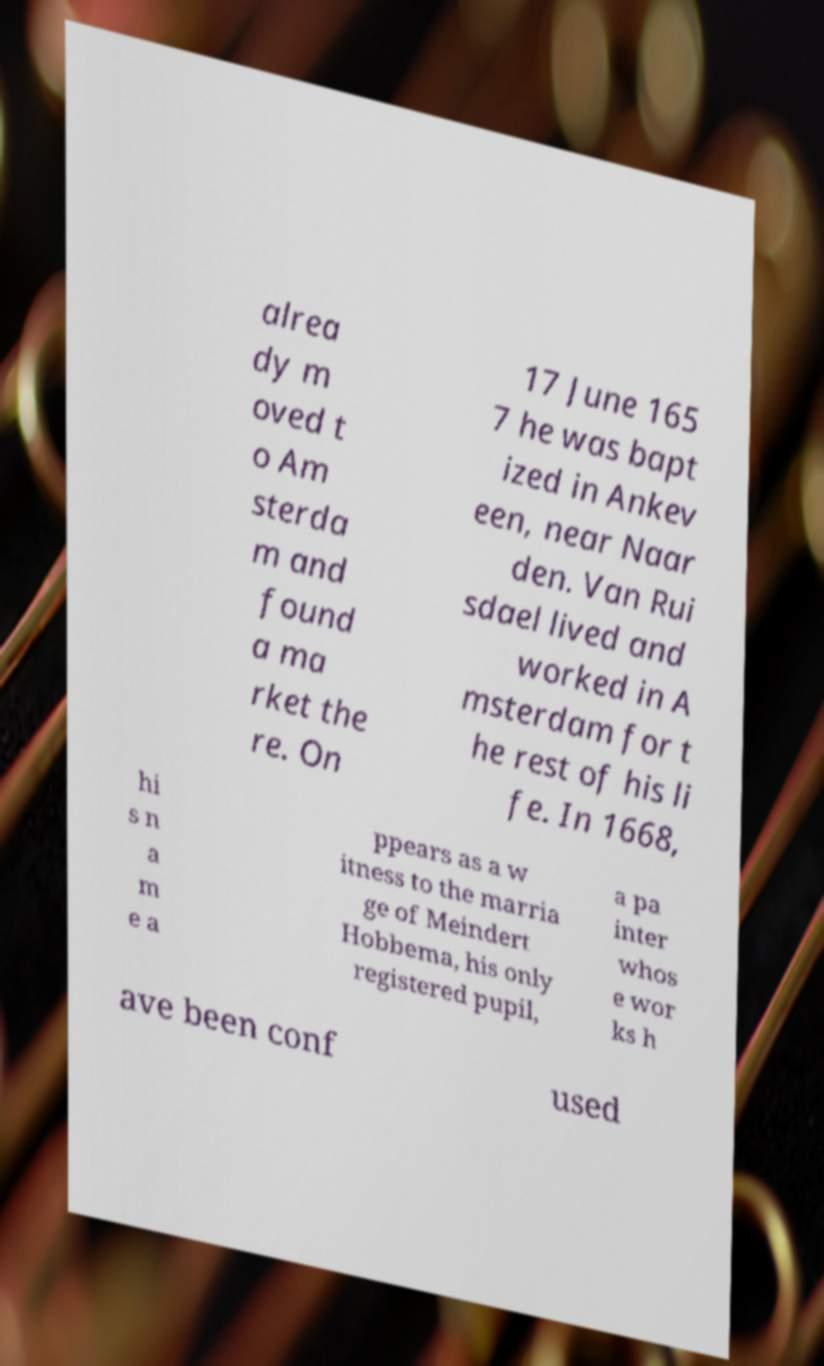Please identify and transcribe the text found in this image. alrea dy m oved t o Am sterda m and found a ma rket the re. On 17 June 165 7 he was bapt ized in Ankev een, near Naar den. Van Rui sdael lived and worked in A msterdam for t he rest of his li fe. In 1668, hi s n a m e a ppears as a w itness to the marria ge of Meindert Hobbema, his only registered pupil, a pa inter whos e wor ks h ave been conf used 